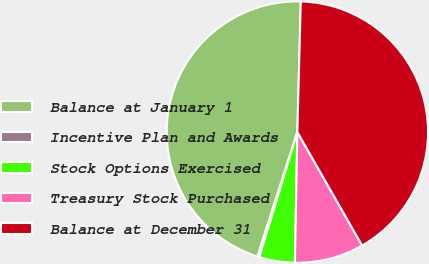Convert chart to OTSL. <chart><loc_0><loc_0><loc_500><loc_500><pie_chart><fcel>Balance at January 1<fcel>Incentive Plan and Awards<fcel>Stock Options Exercised<fcel>Treasury Stock Purchased<fcel>Balance at December 31<nl><fcel>45.48%<fcel>0.24%<fcel>4.4%<fcel>8.55%<fcel>41.33%<nl></chart> 